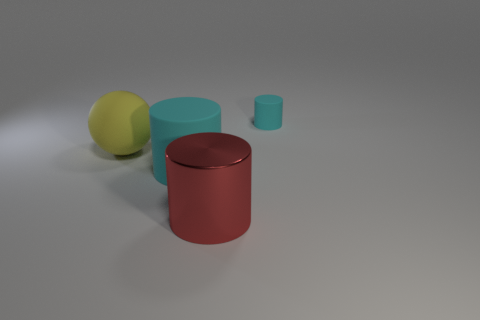Subtract all matte cylinders. How many cylinders are left? 1 Add 1 matte cylinders. How many objects exist? 5 Subtract all cyan cylinders. How many cylinders are left? 1 Subtract all balls. How many objects are left? 3 Subtract 0 brown spheres. How many objects are left? 4 Subtract 2 cylinders. How many cylinders are left? 1 Subtract all gray cylinders. Subtract all cyan cubes. How many cylinders are left? 3 Subtract all red cubes. How many red cylinders are left? 1 Subtract all tiny brown spheres. Subtract all tiny cyan objects. How many objects are left? 3 Add 3 red objects. How many red objects are left? 4 